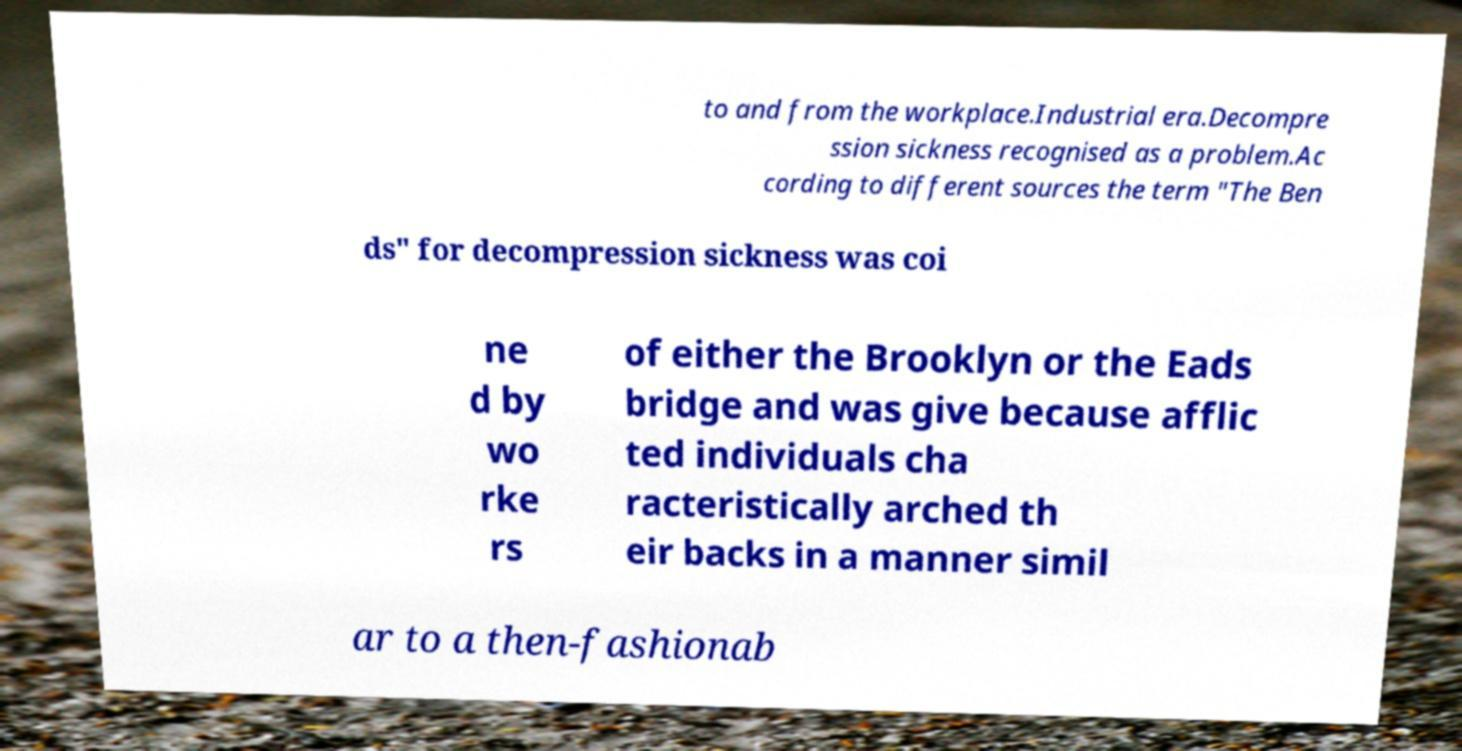Please read and relay the text visible in this image. What does it say? to and from the workplace.Industrial era.Decompre ssion sickness recognised as a problem.Ac cording to different sources the term "The Ben ds" for decompression sickness was coi ne d by wo rke rs of either the Brooklyn or the Eads bridge and was give because afflic ted individuals cha racteristically arched th eir backs in a manner simil ar to a then-fashionab 